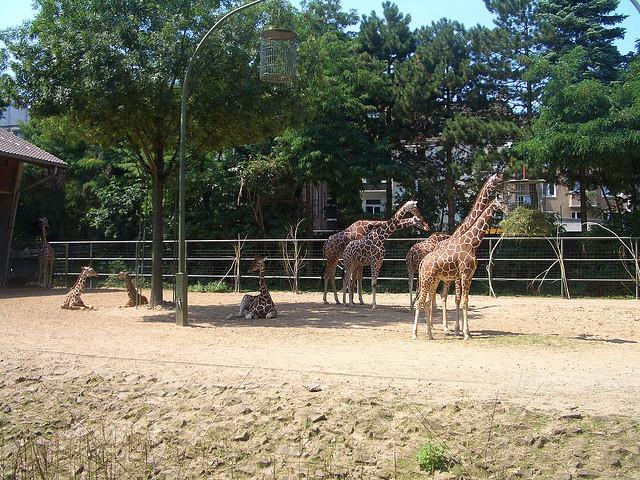What animals can be seen? giraffes 